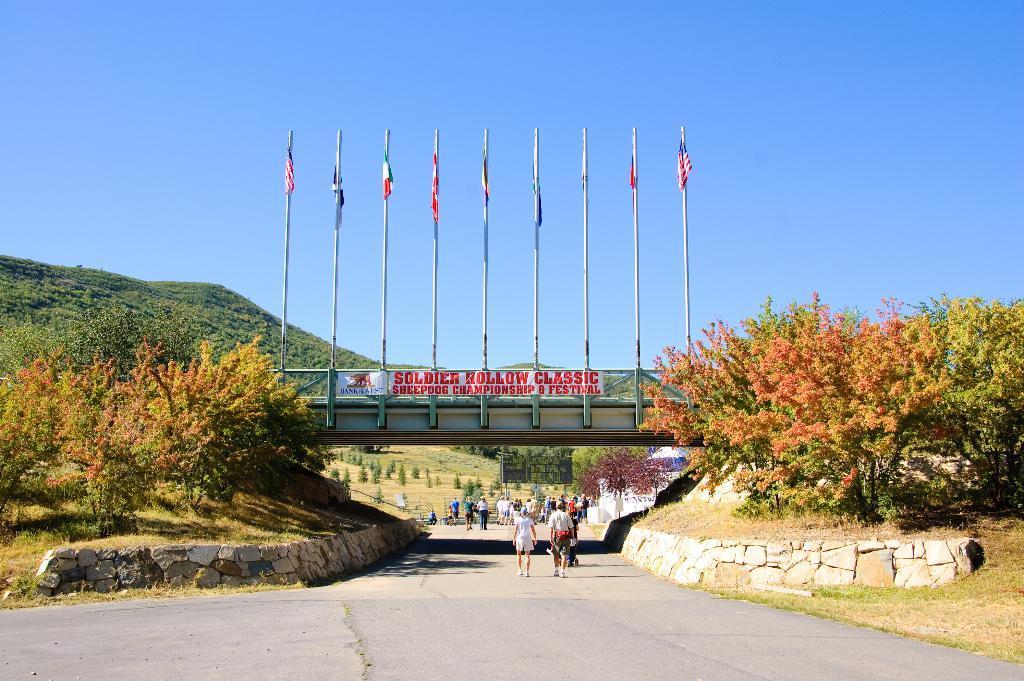In one or two sentences, can you explain what this image depicts? In this image we can see some people on the ground. In the center of the image we can see some flags on poles, bridge and a banner with some text. On the left and right side of the image we can see a group of trees. In the background, we can see a hill and the sky. 